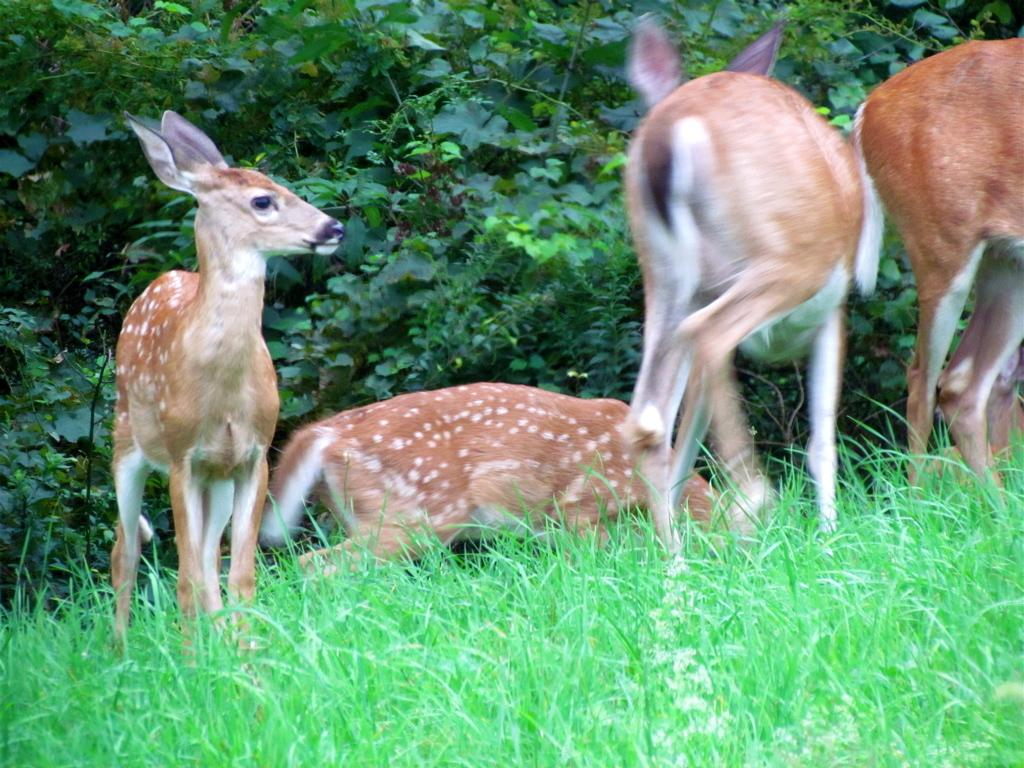What animals can be seen in the image? There are deer in the image. What colors are the deer? The deer are brown and white in color. What can be seen in the background of the image? There are trees and grass visible in the background of the image. How many icicles are hanging from the deer's antlers in the image? There are no icicles present in the image; the deer are brown and white in color and are not associated with icicles. 